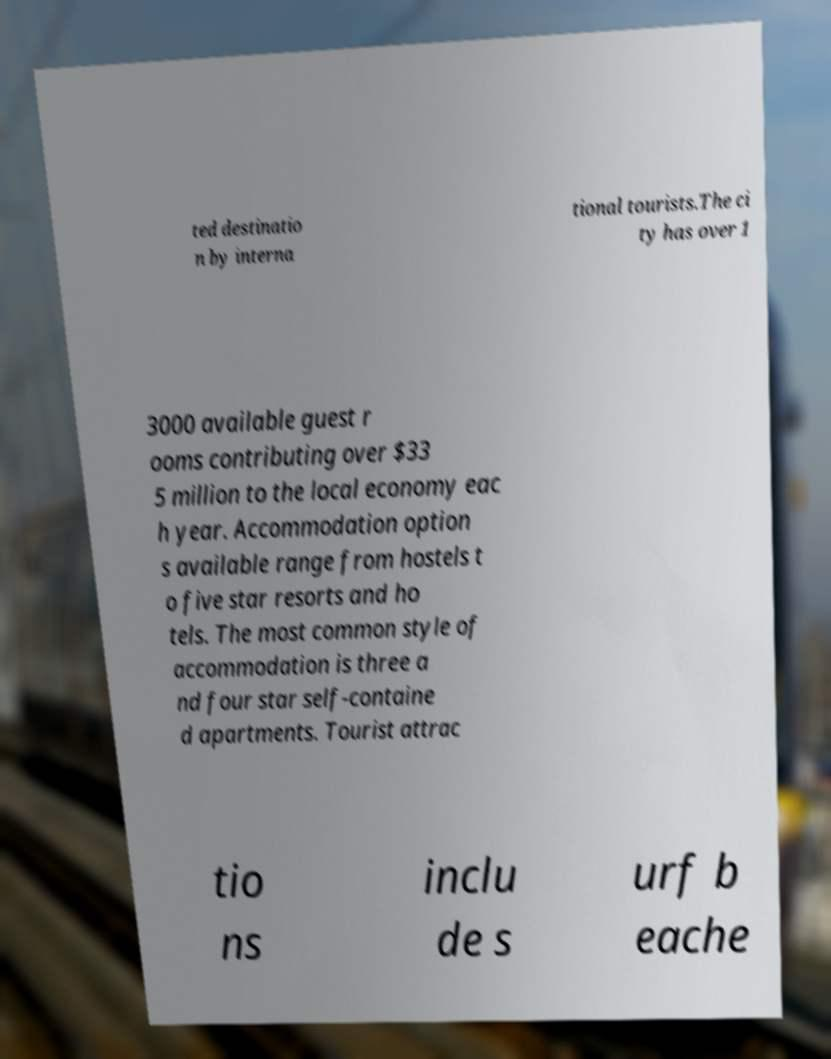Can you accurately transcribe the text from the provided image for me? ted destinatio n by interna tional tourists.The ci ty has over 1 3000 available guest r ooms contributing over $33 5 million to the local economy eac h year. Accommodation option s available range from hostels t o five star resorts and ho tels. The most common style of accommodation is three a nd four star self-containe d apartments. Tourist attrac tio ns inclu de s urf b eache 